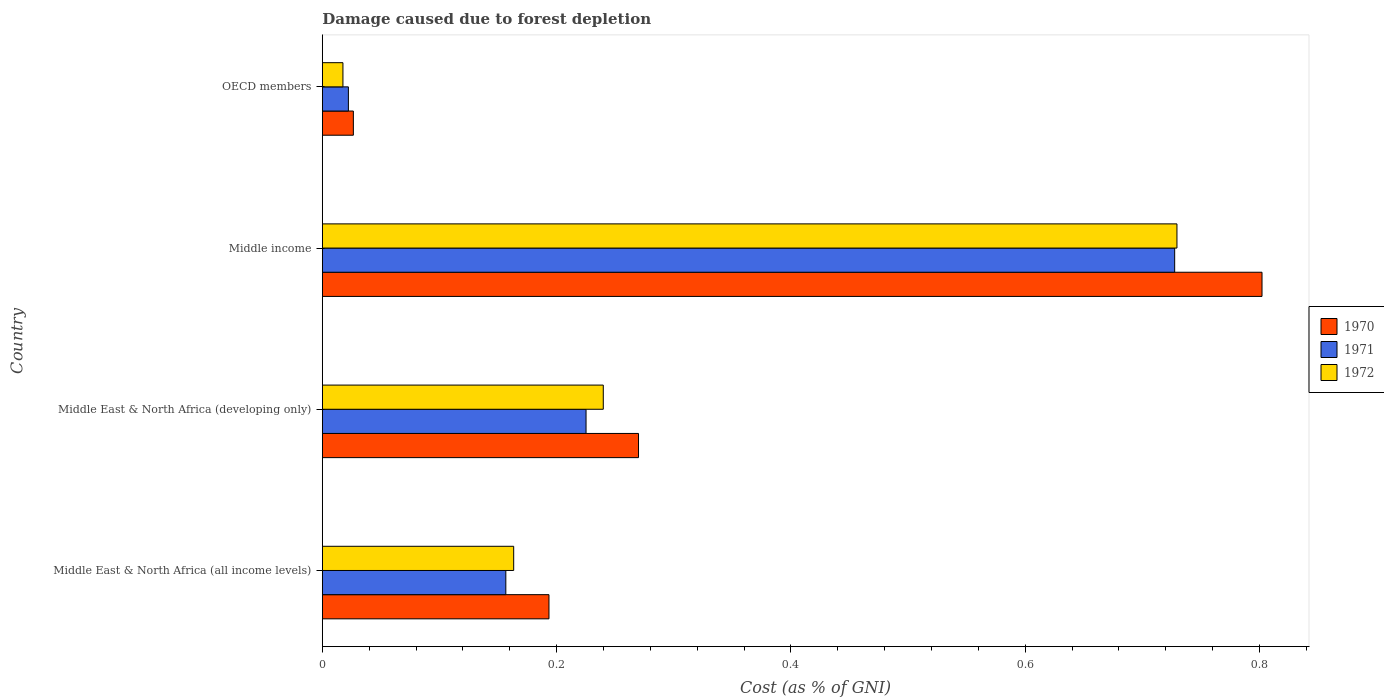Are the number of bars per tick equal to the number of legend labels?
Provide a short and direct response. Yes. Are the number of bars on each tick of the Y-axis equal?
Your response must be concise. Yes. How many bars are there on the 1st tick from the top?
Keep it short and to the point. 3. How many bars are there on the 3rd tick from the bottom?
Offer a very short reply. 3. What is the label of the 1st group of bars from the top?
Ensure brevity in your answer.  OECD members. What is the cost of damage caused due to forest depletion in 1970 in Middle East & North Africa (developing only)?
Offer a very short reply. 0.27. Across all countries, what is the maximum cost of damage caused due to forest depletion in 1971?
Your answer should be very brief. 0.73. Across all countries, what is the minimum cost of damage caused due to forest depletion in 1972?
Give a very brief answer. 0.02. What is the total cost of damage caused due to forest depletion in 1972 in the graph?
Ensure brevity in your answer.  1.15. What is the difference between the cost of damage caused due to forest depletion in 1972 in Middle East & North Africa (all income levels) and that in OECD members?
Give a very brief answer. 0.15. What is the difference between the cost of damage caused due to forest depletion in 1972 in Middle East & North Africa (developing only) and the cost of damage caused due to forest depletion in 1970 in OECD members?
Make the answer very short. 0.21. What is the average cost of damage caused due to forest depletion in 1970 per country?
Offer a very short reply. 0.32. What is the difference between the cost of damage caused due to forest depletion in 1971 and cost of damage caused due to forest depletion in 1970 in Middle East & North Africa (developing only)?
Ensure brevity in your answer.  -0.04. In how many countries, is the cost of damage caused due to forest depletion in 1972 greater than 0.04 %?
Give a very brief answer. 3. What is the ratio of the cost of damage caused due to forest depletion in 1972 in Middle East & North Africa (developing only) to that in OECD members?
Your answer should be compact. 13.63. What is the difference between the highest and the second highest cost of damage caused due to forest depletion in 1971?
Offer a very short reply. 0.5. What is the difference between the highest and the lowest cost of damage caused due to forest depletion in 1970?
Offer a very short reply. 0.78. Is the sum of the cost of damage caused due to forest depletion in 1972 in Middle East & North Africa (all income levels) and OECD members greater than the maximum cost of damage caused due to forest depletion in 1971 across all countries?
Your answer should be compact. No. What does the 2nd bar from the top in Middle East & North Africa (developing only) represents?
Your answer should be very brief. 1971. What is the difference between two consecutive major ticks on the X-axis?
Ensure brevity in your answer.  0.2. Are the values on the major ticks of X-axis written in scientific E-notation?
Offer a terse response. No. Does the graph contain any zero values?
Provide a short and direct response. No. Where does the legend appear in the graph?
Provide a short and direct response. Center right. How are the legend labels stacked?
Give a very brief answer. Vertical. What is the title of the graph?
Provide a short and direct response. Damage caused due to forest depletion. Does "1998" appear as one of the legend labels in the graph?
Your response must be concise. No. What is the label or title of the X-axis?
Keep it short and to the point. Cost (as % of GNI). What is the label or title of the Y-axis?
Provide a short and direct response. Country. What is the Cost (as % of GNI) of 1970 in Middle East & North Africa (all income levels)?
Provide a succinct answer. 0.19. What is the Cost (as % of GNI) in 1971 in Middle East & North Africa (all income levels)?
Offer a terse response. 0.16. What is the Cost (as % of GNI) of 1972 in Middle East & North Africa (all income levels)?
Give a very brief answer. 0.16. What is the Cost (as % of GNI) in 1970 in Middle East & North Africa (developing only)?
Offer a very short reply. 0.27. What is the Cost (as % of GNI) in 1971 in Middle East & North Africa (developing only)?
Your answer should be very brief. 0.23. What is the Cost (as % of GNI) of 1972 in Middle East & North Africa (developing only)?
Provide a short and direct response. 0.24. What is the Cost (as % of GNI) of 1970 in Middle income?
Provide a short and direct response. 0.8. What is the Cost (as % of GNI) in 1971 in Middle income?
Give a very brief answer. 0.73. What is the Cost (as % of GNI) of 1972 in Middle income?
Ensure brevity in your answer.  0.73. What is the Cost (as % of GNI) in 1970 in OECD members?
Provide a short and direct response. 0.03. What is the Cost (as % of GNI) of 1971 in OECD members?
Keep it short and to the point. 0.02. What is the Cost (as % of GNI) in 1972 in OECD members?
Ensure brevity in your answer.  0.02. Across all countries, what is the maximum Cost (as % of GNI) in 1970?
Keep it short and to the point. 0.8. Across all countries, what is the maximum Cost (as % of GNI) of 1971?
Make the answer very short. 0.73. Across all countries, what is the maximum Cost (as % of GNI) of 1972?
Ensure brevity in your answer.  0.73. Across all countries, what is the minimum Cost (as % of GNI) of 1970?
Provide a short and direct response. 0.03. Across all countries, what is the minimum Cost (as % of GNI) in 1971?
Your answer should be very brief. 0.02. Across all countries, what is the minimum Cost (as % of GNI) in 1972?
Your answer should be compact. 0.02. What is the total Cost (as % of GNI) of 1970 in the graph?
Provide a short and direct response. 1.29. What is the total Cost (as % of GNI) of 1971 in the graph?
Offer a terse response. 1.13. What is the total Cost (as % of GNI) of 1972 in the graph?
Ensure brevity in your answer.  1.15. What is the difference between the Cost (as % of GNI) of 1970 in Middle East & North Africa (all income levels) and that in Middle East & North Africa (developing only)?
Provide a succinct answer. -0.08. What is the difference between the Cost (as % of GNI) of 1971 in Middle East & North Africa (all income levels) and that in Middle East & North Africa (developing only)?
Keep it short and to the point. -0.07. What is the difference between the Cost (as % of GNI) of 1972 in Middle East & North Africa (all income levels) and that in Middle East & North Africa (developing only)?
Make the answer very short. -0.08. What is the difference between the Cost (as % of GNI) of 1970 in Middle East & North Africa (all income levels) and that in Middle income?
Your answer should be compact. -0.61. What is the difference between the Cost (as % of GNI) of 1971 in Middle East & North Africa (all income levels) and that in Middle income?
Ensure brevity in your answer.  -0.57. What is the difference between the Cost (as % of GNI) of 1972 in Middle East & North Africa (all income levels) and that in Middle income?
Your answer should be very brief. -0.57. What is the difference between the Cost (as % of GNI) in 1970 in Middle East & North Africa (all income levels) and that in OECD members?
Ensure brevity in your answer.  0.17. What is the difference between the Cost (as % of GNI) in 1971 in Middle East & North Africa (all income levels) and that in OECD members?
Make the answer very short. 0.13. What is the difference between the Cost (as % of GNI) in 1972 in Middle East & North Africa (all income levels) and that in OECD members?
Make the answer very short. 0.15. What is the difference between the Cost (as % of GNI) in 1970 in Middle East & North Africa (developing only) and that in Middle income?
Offer a terse response. -0.53. What is the difference between the Cost (as % of GNI) in 1971 in Middle East & North Africa (developing only) and that in Middle income?
Give a very brief answer. -0.5. What is the difference between the Cost (as % of GNI) in 1972 in Middle East & North Africa (developing only) and that in Middle income?
Keep it short and to the point. -0.49. What is the difference between the Cost (as % of GNI) of 1970 in Middle East & North Africa (developing only) and that in OECD members?
Keep it short and to the point. 0.24. What is the difference between the Cost (as % of GNI) in 1971 in Middle East & North Africa (developing only) and that in OECD members?
Offer a terse response. 0.2. What is the difference between the Cost (as % of GNI) of 1972 in Middle East & North Africa (developing only) and that in OECD members?
Offer a very short reply. 0.22. What is the difference between the Cost (as % of GNI) in 1970 in Middle income and that in OECD members?
Your response must be concise. 0.78. What is the difference between the Cost (as % of GNI) in 1971 in Middle income and that in OECD members?
Provide a short and direct response. 0.71. What is the difference between the Cost (as % of GNI) in 1972 in Middle income and that in OECD members?
Offer a very short reply. 0.71. What is the difference between the Cost (as % of GNI) of 1970 in Middle East & North Africa (all income levels) and the Cost (as % of GNI) of 1971 in Middle East & North Africa (developing only)?
Offer a terse response. -0.03. What is the difference between the Cost (as % of GNI) in 1970 in Middle East & North Africa (all income levels) and the Cost (as % of GNI) in 1972 in Middle East & North Africa (developing only)?
Offer a very short reply. -0.05. What is the difference between the Cost (as % of GNI) of 1971 in Middle East & North Africa (all income levels) and the Cost (as % of GNI) of 1972 in Middle East & North Africa (developing only)?
Give a very brief answer. -0.08. What is the difference between the Cost (as % of GNI) of 1970 in Middle East & North Africa (all income levels) and the Cost (as % of GNI) of 1971 in Middle income?
Ensure brevity in your answer.  -0.53. What is the difference between the Cost (as % of GNI) in 1970 in Middle East & North Africa (all income levels) and the Cost (as % of GNI) in 1972 in Middle income?
Offer a very short reply. -0.54. What is the difference between the Cost (as % of GNI) of 1971 in Middle East & North Africa (all income levels) and the Cost (as % of GNI) of 1972 in Middle income?
Ensure brevity in your answer.  -0.57. What is the difference between the Cost (as % of GNI) in 1970 in Middle East & North Africa (all income levels) and the Cost (as % of GNI) in 1971 in OECD members?
Offer a very short reply. 0.17. What is the difference between the Cost (as % of GNI) of 1970 in Middle East & North Africa (all income levels) and the Cost (as % of GNI) of 1972 in OECD members?
Offer a very short reply. 0.18. What is the difference between the Cost (as % of GNI) of 1971 in Middle East & North Africa (all income levels) and the Cost (as % of GNI) of 1972 in OECD members?
Give a very brief answer. 0.14. What is the difference between the Cost (as % of GNI) of 1970 in Middle East & North Africa (developing only) and the Cost (as % of GNI) of 1971 in Middle income?
Your answer should be very brief. -0.46. What is the difference between the Cost (as % of GNI) of 1970 in Middle East & North Africa (developing only) and the Cost (as % of GNI) of 1972 in Middle income?
Give a very brief answer. -0.46. What is the difference between the Cost (as % of GNI) of 1971 in Middle East & North Africa (developing only) and the Cost (as % of GNI) of 1972 in Middle income?
Make the answer very short. -0.5. What is the difference between the Cost (as % of GNI) in 1970 in Middle East & North Africa (developing only) and the Cost (as % of GNI) in 1971 in OECD members?
Keep it short and to the point. 0.25. What is the difference between the Cost (as % of GNI) of 1970 in Middle East & North Africa (developing only) and the Cost (as % of GNI) of 1972 in OECD members?
Your answer should be compact. 0.25. What is the difference between the Cost (as % of GNI) in 1971 in Middle East & North Africa (developing only) and the Cost (as % of GNI) in 1972 in OECD members?
Your answer should be compact. 0.21. What is the difference between the Cost (as % of GNI) of 1970 in Middle income and the Cost (as % of GNI) of 1971 in OECD members?
Keep it short and to the point. 0.78. What is the difference between the Cost (as % of GNI) of 1970 in Middle income and the Cost (as % of GNI) of 1972 in OECD members?
Give a very brief answer. 0.78. What is the difference between the Cost (as % of GNI) in 1971 in Middle income and the Cost (as % of GNI) in 1972 in OECD members?
Make the answer very short. 0.71. What is the average Cost (as % of GNI) of 1970 per country?
Your response must be concise. 0.32. What is the average Cost (as % of GNI) of 1971 per country?
Ensure brevity in your answer.  0.28. What is the average Cost (as % of GNI) in 1972 per country?
Give a very brief answer. 0.29. What is the difference between the Cost (as % of GNI) in 1970 and Cost (as % of GNI) in 1971 in Middle East & North Africa (all income levels)?
Provide a succinct answer. 0.04. What is the difference between the Cost (as % of GNI) in 1970 and Cost (as % of GNI) in 1972 in Middle East & North Africa (all income levels)?
Make the answer very short. 0.03. What is the difference between the Cost (as % of GNI) in 1971 and Cost (as % of GNI) in 1972 in Middle East & North Africa (all income levels)?
Make the answer very short. -0.01. What is the difference between the Cost (as % of GNI) in 1970 and Cost (as % of GNI) in 1971 in Middle East & North Africa (developing only)?
Keep it short and to the point. 0.04. What is the difference between the Cost (as % of GNI) of 1970 and Cost (as % of GNI) of 1972 in Middle East & North Africa (developing only)?
Ensure brevity in your answer.  0.03. What is the difference between the Cost (as % of GNI) of 1971 and Cost (as % of GNI) of 1972 in Middle East & North Africa (developing only)?
Provide a short and direct response. -0.01. What is the difference between the Cost (as % of GNI) in 1970 and Cost (as % of GNI) in 1971 in Middle income?
Your answer should be compact. 0.07. What is the difference between the Cost (as % of GNI) in 1970 and Cost (as % of GNI) in 1972 in Middle income?
Ensure brevity in your answer.  0.07. What is the difference between the Cost (as % of GNI) in 1971 and Cost (as % of GNI) in 1972 in Middle income?
Your response must be concise. -0. What is the difference between the Cost (as % of GNI) in 1970 and Cost (as % of GNI) in 1971 in OECD members?
Give a very brief answer. 0. What is the difference between the Cost (as % of GNI) in 1970 and Cost (as % of GNI) in 1972 in OECD members?
Give a very brief answer. 0.01. What is the difference between the Cost (as % of GNI) in 1971 and Cost (as % of GNI) in 1972 in OECD members?
Provide a succinct answer. 0. What is the ratio of the Cost (as % of GNI) of 1970 in Middle East & North Africa (all income levels) to that in Middle East & North Africa (developing only)?
Ensure brevity in your answer.  0.72. What is the ratio of the Cost (as % of GNI) in 1971 in Middle East & North Africa (all income levels) to that in Middle East & North Africa (developing only)?
Your answer should be very brief. 0.7. What is the ratio of the Cost (as % of GNI) in 1972 in Middle East & North Africa (all income levels) to that in Middle East & North Africa (developing only)?
Provide a short and direct response. 0.68. What is the ratio of the Cost (as % of GNI) in 1970 in Middle East & North Africa (all income levels) to that in Middle income?
Offer a very short reply. 0.24. What is the ratio of the Cost (as % of GNI) of 1971 in Middle East & North Africa (all income levels) to that in Middle income?
Keep it short and to the point. 0.22. What is the ratio of the Cost (as % of GNI) of 1972 in Middle East & North Africa (all income levels) to that in Middle income?
Offer a terse response. 0.22. What is the ratio of the Cost (as % of GNI) in 1970 in Middle East & North Africa (all income levels) to that in OECD members?
Offer a terse response. 7.3. What is the ratio of the Cost (as % of GNI) in 1971 in Middle East & North Africa (all income levels) to that in OECD members?
Make the answer very short. 7.04. What is the ratio of the Cost (as % of GNI) in 1972 in Middle East & North Africa (all income levels) to that in OECD members?
Your answer should be very brief. 9.29. What is the ratio of the Cost (as % of GNI) of 1970 in Middle East & North Africa (developing only) to that in Middle income?
Keep it short and to the point. 0.34. What is the ratio of the Cost (as % of GNI) of 1971 in Middle East & North Africa (developing only) to that in Middle income?
Keep it short and to the point. 0.31. What is the ratio of the Cost (as % of GNI) of 1972 in Middle East & North Africa (developing only) to that in Middle income?
Offer a terse response. 0.33. What is the ratio of the Cost (as % of GNI) in 1970 in Middle East & North Africa (developing only) to that in OECD members?
Ensure brevity in your answer.  10.19. What is the ratio of the Cost (as % of GNI) of 1971 in Middle East & North Africa (developing only) to that in OECD members?
Offer a very short reply. 10.12. What is the ratio of the Cost (as % of GNI) of 1972 in Middle East & North Africa (developing only) to that in OECD members?
Keep it short and to the point. 13.63. What is the ratio of the Cost (as % of GNI) in 1970 in Middle income to that in OECD members?
Your response must be concise. 30.28. What is the ratio of the Cost (as % of GNI) of 1971 in Middle income to that in OECD members?
Make the answer very short. 32.71. What is the ratio of the Cost (as % of GNI) of 1972 in Middle income to that in OECD members?
Provide a short and direct response. 41.48. What is the difference between the highest and the second highest Cost (as % of GNI) in 1970?
Offer a very short reply. 0.53. What is the difference between the highest and the second highest Cost (as % of GNI) in 1971?
Your answer should be compact. 0.5. What is the difference between the highest and the second highest Cost (as % of GNI) of 1972?
Your answer should be compact. 0.49. What is the difference between the highest and the lowest Cost (as % of GNI) of 1970?
Offer a very short reply. 0.78. What is the difference between the highest and the lowest Cost (as % of GNI) of 1971?
Your answer should be compact. 0.71. What is the difference between the highest and the lowest Cost (as % of GNI) of 1972?
Offer a very short reply. 0.71. 